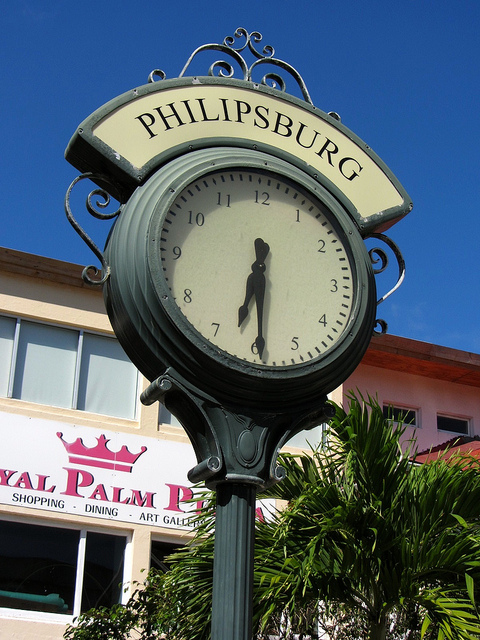Identify the text displayed in this image. PHILISPBURG 12 1 11 10 YAL P PALM GALLERY ART DINING SHOPPING 2 3 4 5 6 7 8 9 